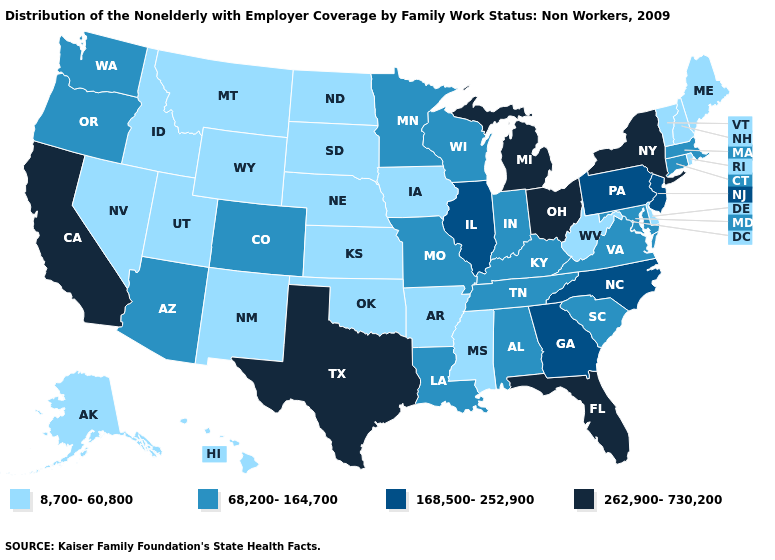Which states hav the highest value in the Northeast?
Concise answer only. New York. What is the highest value in states that border Georgia?
Answer briefly. 262,900-730,200. Which states have the highest value in the USA?
Give a very brief answer. California, Florida, Michigan, New York, Ohio, Texas. What is the lowest value in the South?
Keep it brief. 8,700-60,800. What is the highest value in the USA?
Give a very brief answer. 262,900-730,200. What is the value of South Carolina?
Short answer required. 68,200-164,700. Name the states that have a value in the range 262,900-730,200?
Quick response, please. California, Florida, Michigan, New York, Ohio, Texas. How many symbols are there in the legend?
Quick response, please. 4. Name the states that have a value in the range 68,200-164,700?
Be succinct. Alabama, Arizona, Colorado, Connecticut, Indiana, Kentucky, Louisiana, Maryland, Massachusetts, Minnesota, Missouri, Oregon, South Carolina, Tennessee, Virginia, Washington, Wisconsin. Does New Hampshire have the highest value in the USA?
Short answer required. No. Does the map have missing data?
Write a very short answer. No. Name the states that have a value in the range 8,700-60,800?
Answer briefly. Alaska, Arkansas, Delaware, Hawaii, Idaho, Iowa, Kansas, Maine, Mississippi, Montana, Nebraska, Nevada, New Hampshire, New Mexico, North Dakota, Oklahoma, Rhode Island, South Dakota, Utah, Vermont, West Virginia, Wyoming. What is the value of Maine?
Short answer required. 8,700-60,800. What is the value of Kansas?
Quick response, please. 8,700-60,800. Among the states that border North Carolina , does Georgia have the highest value?
Give a very brief answer. Yes. 